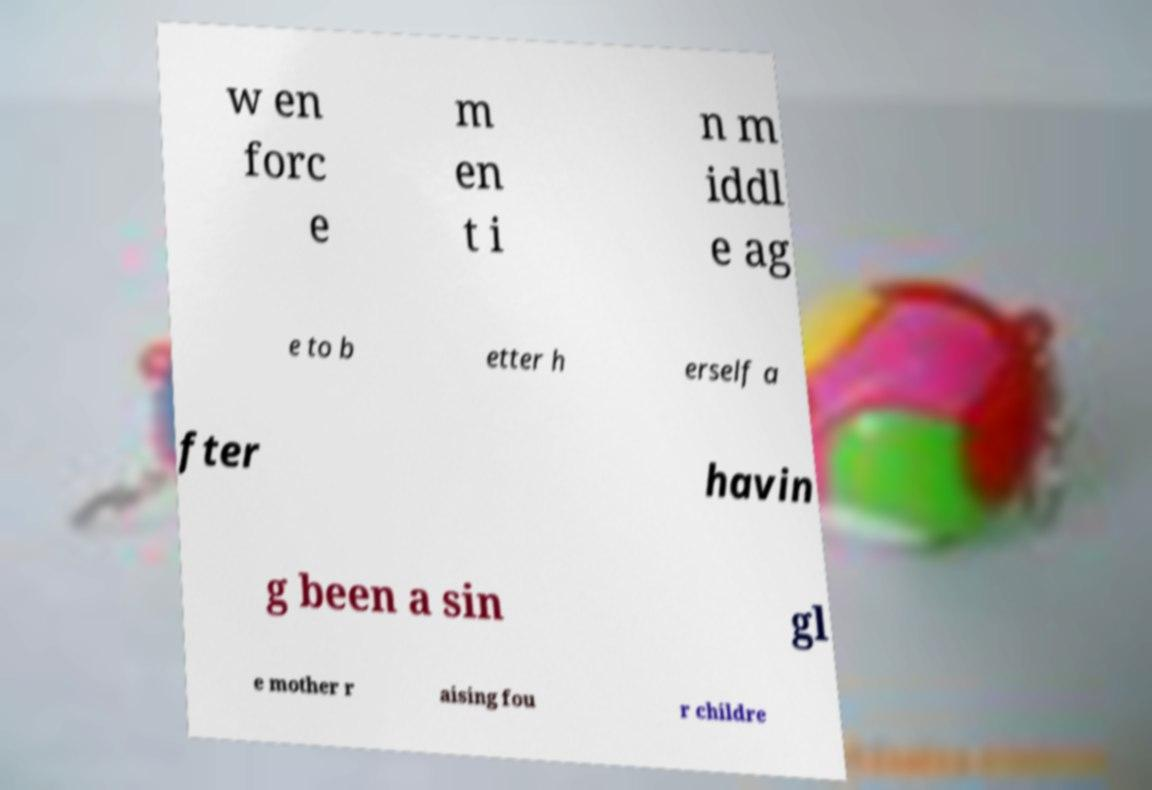Can you accurately transcribe the text from the provided image for me? w en forc e m en t i n m iddl e ag e to b etter h erself a fter havin g been a sin gl e mother r aising fou r childre 